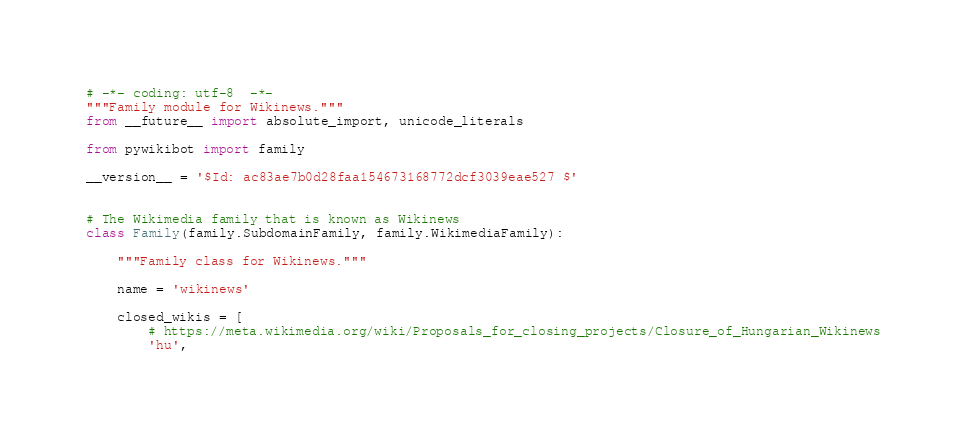<code> <loc_0><loc_0><loc_500><loc_500><_Python_># -*- coding: utf-8  -*-
"""Family module for Wikinews."""
from __future__ import absolute_import, unicode_literals

from pywikibot import family

__version__ = '$Id: ac83ae7b0d28faa154673168772dcf3039eae527 $'


# The Wikimedia family that is known as Wikinews
class Family(family.SubdomainFamily, family.WikimediaFamily):

    """Family class for Wikinews."""

    name = 'wikinews'

    closed_wikis = [
        # https://meta.wikimedia.org/wiki/Proposals_for_closing_projects/Closure_of_Hungarian_Wikinews
        'hu',</code> 